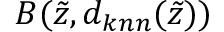Convert formula to latex. <formula><loc_0><loc_0><loc_500><loc_500>B ( \tilde { z } , d _ { k n n } ( \tilde { z } ) )</formula> 